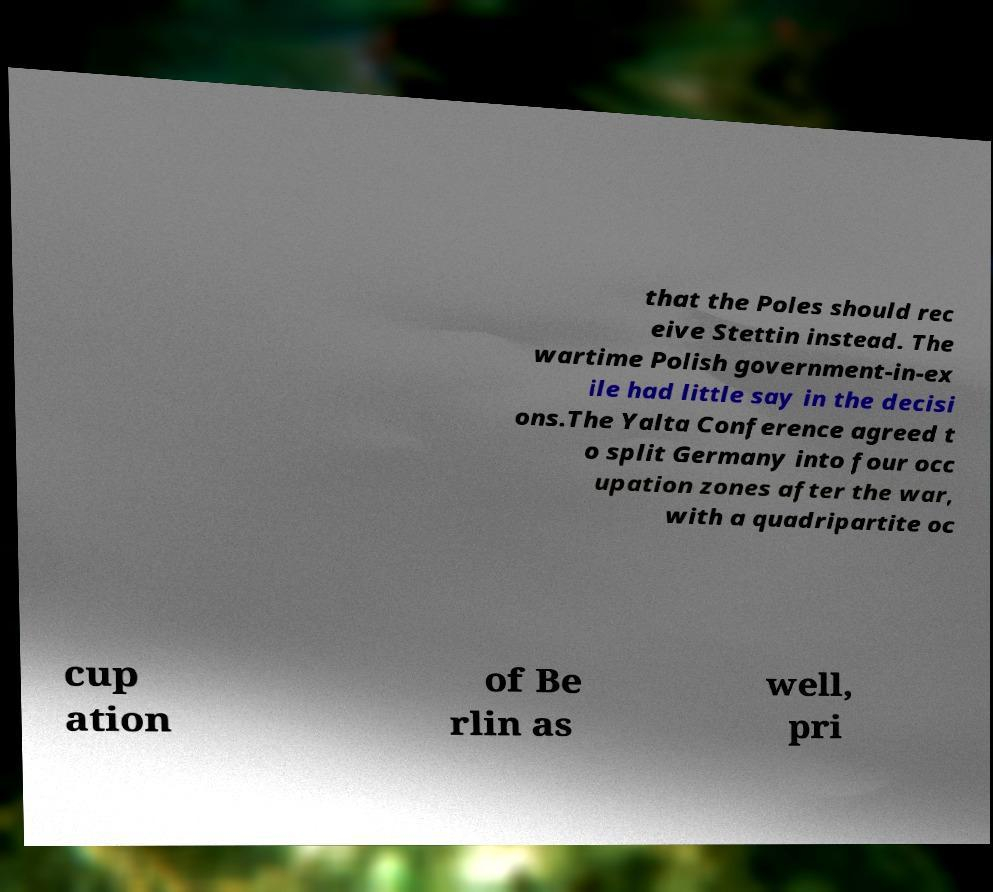Could you assist in decoding the text presented in this image and type it out clearly? that the Poles should rec eive Stettin instead. The wartime Polish government-in-ex ile had little say in the decisi ons.The Yalta Conference agreed t o split Germany into four occ upation zones after the war, with a quadripartite oc cup ation of Be rlin as well, pri 